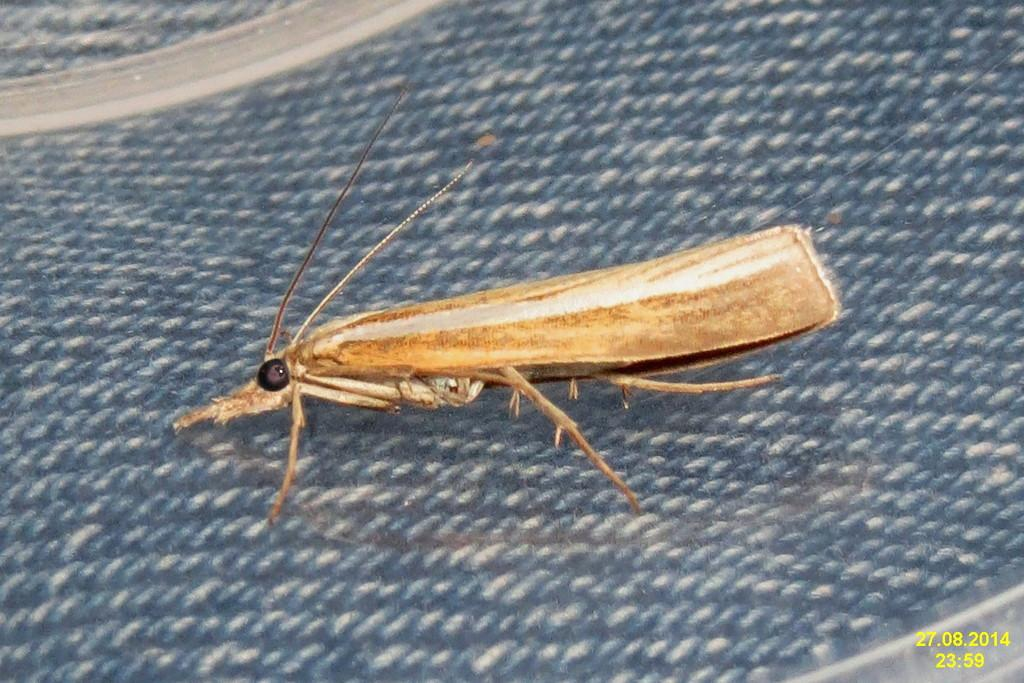What type of creature is in the image? There is an insect in the image. What color is the surface the insect is on? The insect is on a blue surface. Where can the date and time be found in the image? The date and time are present at the bottom right of the image. What type of butter is being spread on the turkey in the image? There is no turkey or butter present in the image; it features an insect on a blue surface. How many waves can be seen crashing on the shore in the image? There are no waves or shoreline present in the image. 